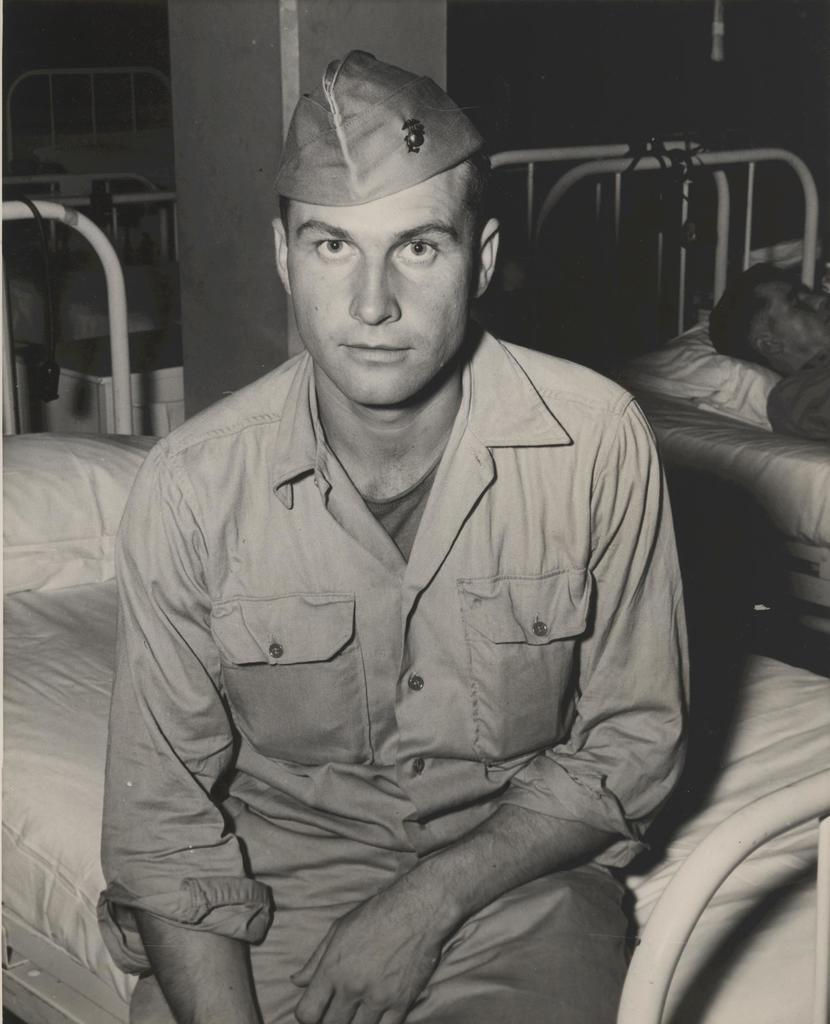What is the person in the image wearing on their head? The person in the image is wearing a hat. What is the person doing in the image? The person is sitting on a bed. What is on the bed besides the person sitting? There is a pillow on the bed. Is there anyone else on the bed in the image? Yes, there is another person laying on the bed. What type of fowl can be seen in the park in the image? There is no park or fowl present in the image; it features a person sitting on a bed with another person laying on it. 